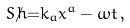<formula> <loc_0><loc_0><loc_500><loc_500>S / \hbar { = } k _ { a } x ^ { a } - \omega t \, ,</formula> 